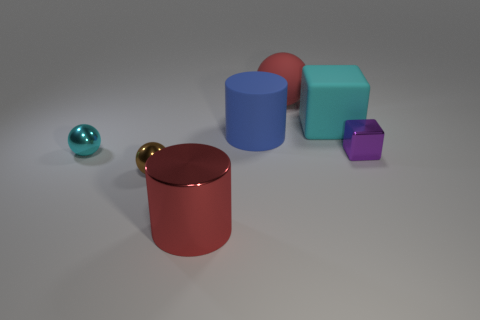How would you compare and contrast the textures of the objects? The objects in the image have two distinct textures, which can be described as 'shiny' and 'matte.' The teal and gold spheres, along with the large red cylinder, all have highly reflective, shiny surfaces that catch the light, creating bright highlights and clear reflections. On the other hand, the blue, orange, and purple cubes showcase a matte finish with diffuse light reflection, giving them a more muted appearance with less pronounced highlights. 